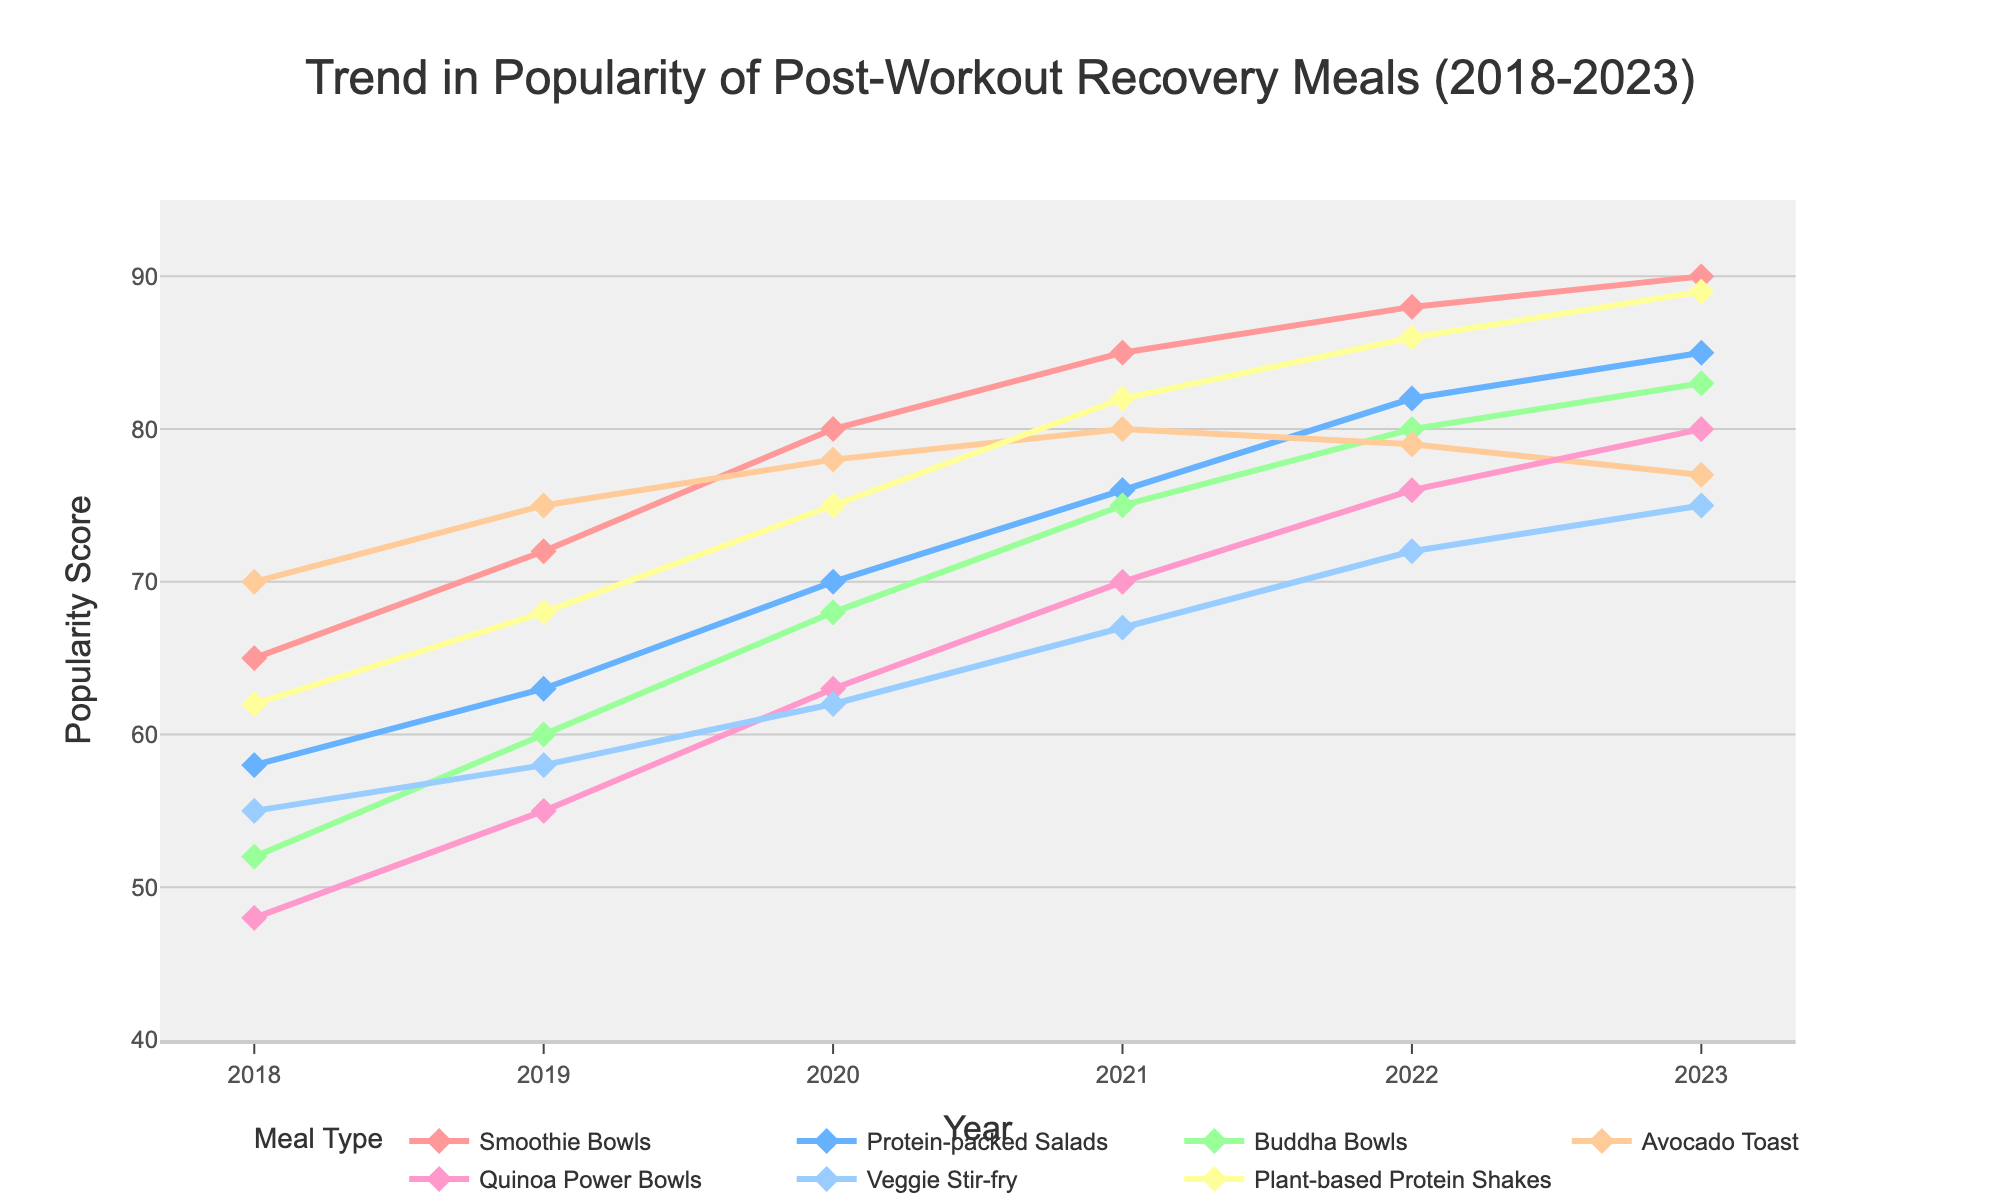What's the most popular post-workout recovery meal in 2023? The highest point on the y-axis for the year 2023 corresponds to the plant-based meal with the label "Plant-based Protein Shakes," which has a value of 89.
Answer: Plant-based Protein Shakes Which plant-based meal shows the greatest increase in popularity from 2018 to 2023? Calculate the difference between 2023 and 2018 values for each meal: Smoothie Bowls increased by 25 (90-65), Protein-packed Salads by 27 (85-58), Buddha Bowls by 31 (83-52), Avocado Toast by 7 (77-70), Quinoa Power Bowls by 32 (80-48), Veggie Stir-fry by 20 (75-55), and Plant-based Protein Shakes by 27 (89-62). Quinoa Power Bowls shows the greatest increase of 32 points.
Answer: Quinoa Power Bowls How did the popularity of Avocado Toast change from 2022 to 2023? The value for Avocado Toast in 2022 was 79, and in 2023 it is 77. This indicates a decrease in popularity by 2 points.
Answer: Decreased by 2 Among the meals listed, which experienced a decline in popularity from 2022 to 2023? Comparing 2022 and 2023 values for each meal, only Avocado Toast shows a decrease from 79 to 77.
Answer: Avocado Toast Which meal had consistent growth every year from 2018 to 2023? By examining the trend lines visually, Smoothie Bowls, Protein-packed Salads, Buddha Bowls, Quinoa Power Bowls, Veggie Stir-fry, and Plant-based Protein Shakes show consistent growth across all years without any dips. Avocado Toast has a decrease in the last year.
Answer: Smoothie Bowls, Protein-packed Salads, Buddha Bowls, Quinoa Power Bowls, Veggie Stir-fry, Plant-based Protein Shakes What is the average popularity score of Buddha Bowls over the 6 years? Sum the popularity scores from 2018 to 2023: 52 + 60 + 68 + 75 + 80 + 83 = 418. Then, divide by the number of years, which is 6. 418/6 = 69.67
Answer: 69.67 Compare the trend lines for Smoothie Bowls and Plant-based Protein Shakes, which one shows a greater popularity increase in the year 2020? For Smoothie Bowls, the change from 2019 to 2020 is 80 - 72 = 8. For Plant-based Protein Shakes, the change from 2019 to 2020 is 75 - 68 = 7. The Smoothie Bowls shows a greater increase.
Answer: Smoothie Bowls What is the difference in popularity between the most popular and least popular meals in 2018? The most popular meal in 2018 is Avocado Toast with a score of 70, and the least popular is Quinoa Power Bowls with a score of 48. The difference is 70 - 48 = 22.
Answer: 22 Which meal had the smallest positive change from 2018 to 2019? Calculate the increase for each meal from 2018 to 2019: Smoothie Bowls increased by 7 (72-65), Protein-packed Salads by 5 (63-58), Buddha Bowls by 8 (60-52), Avocado Toast by 5 (75-70), Quinoa Power Bowls by 7 (55-48), Veggie Stir-fry by 3 (58-55), and Plant-based Protein Shakes by 6 (68-62). The smallest positive change is for Veggie Stir-fry, which increased by 3.
Answer: Veggie Stir-fry By how much did the popularity of Veggie Stir-fry increase from 2021 to 2023? The value for Veggie Stir-fry in 2021 was 67 and in 2023 it is 75. The increase is 75 - 67 = 8.
Answer: 8 